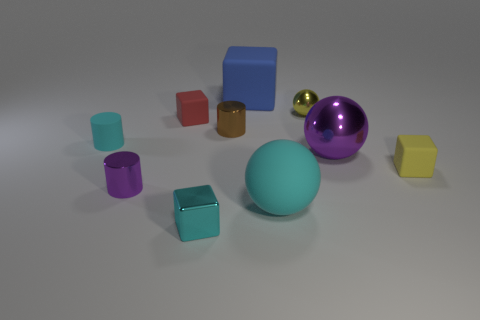Subtract all metal balls. How many balls are left? 1 Subtract all spheres. How many objects are left? 7 Subtract all yellow blocks. How many blocks are left? 3 Subtract 2 blocks. How many blocks are left? 2 Subtract all gray cylinders. Subtract all gray balls. How many cylinders are left? 3 Add 1 blue matte objects. How many blue matte objects exist? 2 Subtract 1 blue cubes. How many objects are left? 9 Subtract all big cyan matte balls. Subtract all tiny red matte things. How many objects are left? 8 Add 6 tiny brown cylinders. How many tiny brown cylinders are left? 7 